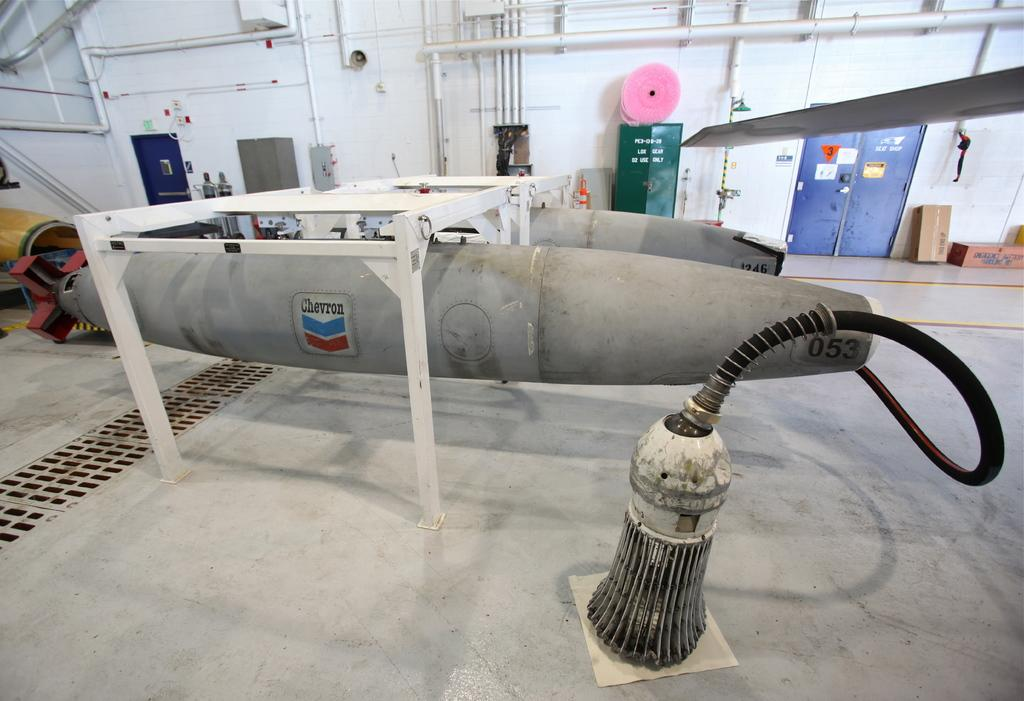What objects are located in the foreground of the image? There are containers in the foreground of the image. What is visible at the bottom of the image? There is a floor visible at the bottom of the image. What can be seen in the background of the image? There is a wall in the background of the image. What features are present on the wall? The wall has pipes, doors, cardboards, and other objects on it. What type of flesh can be seen hanging from the pipes on the wall in the image? There is no flesh present in the image; the pipes on the wall are not associated with any living organisms or biological materials. 